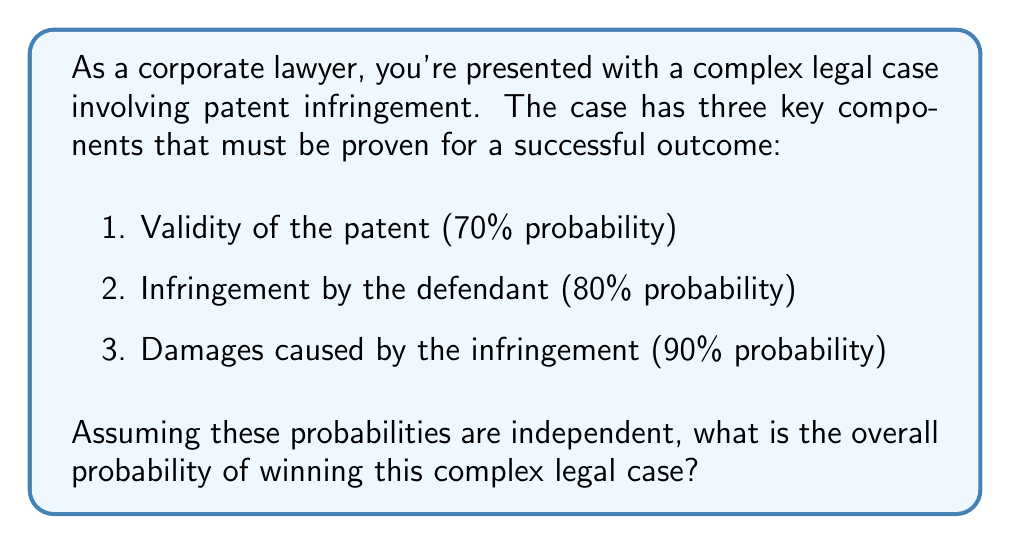Solve this math problem. To solve this problem, we need to apply the multiplication rule of probability for independent events. Since all three components must be proven for a successful outcome, we multiply the individual probabilities:

Let's define the events:
$A$: Validity of the patent
$B$: Infringement by the defendant
$C$: Damages caused by the infringement

Given:
$P(A) = 0.70$
$P(B) = 0.80$
$P(C) = 0.90$

The probability of winning the case is the probability of all three events occurring:

$$P(\text{Winning}) = P(A \cap B \cap C)$$

Since the events are independent:

$$P(A \cap B \cap C) = P(A) \times P(B) \times P(C)$$

Substituting the given probabilities:

$$P(\text{Winning}) = 0.70 \times 0.80 \times 0.90$$

$$P(\text{Winning}) = 0.504$$

Therefore, the probability of winning this complex legal case is 0.504 or 50.4%.
Answer: The probability of winning the complex legal case is 0.504 or 50.4%. 